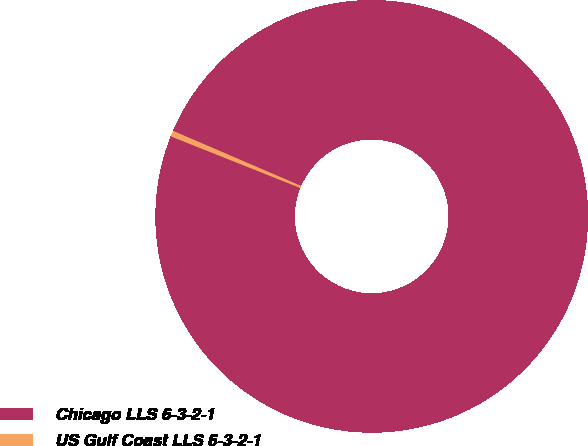Convert chart to OTSL. <chart><loc_0><loc_0><loc_500><loc_500><pie_chart><fcel>Chicago LLS 6-3-2-1<fcel>US Gulf Coast LLS 6-3-2-1<nl><fcel>99.57%<fcel>0.43%<nl></chart> 